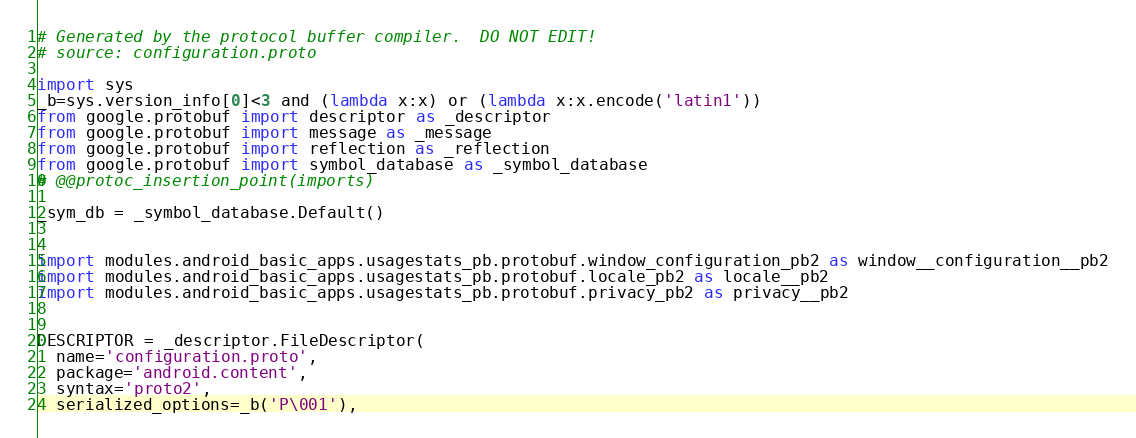Convert code to text. <code><loc_0><loc_0><loc_500><loc_500><_Python_># Generated by the protocol buffer compiler.  DO NOT EDIT!
# source: configuration.proto

import sys
_b=sys.version_info[0]<3 and (lambda x:x) or (lambda x:x.encode('latin1'))
from google.protobuf import descriptor as _descriptor
from google.protobuf import message as _message
from google.protobuf import reflection as _reflection
from google.protobuf import symbol_database as _symbol_database
# @@protoc_insertion_point(imports)

_sym_db = _symbol_database.Default()


import modules.android_basic_apps.usagestats_pb.protobuf.window_configuration_pb2 as window__configuration__pb2
import modules.android_basic_apps.usagestats_pb.protobuf.locale_pb2 as locale__pb2
import modules.android_basic_apps.usagestats_pb.protobuf.privacy_pb2 as privacy__pb2


DESCRIPTOR = _descriptor.FileDescriptor(
  name='configuration.proto',
  package='android.content',
  syntax='proto2',
  serialized_options=_b('P\001'),</code> 